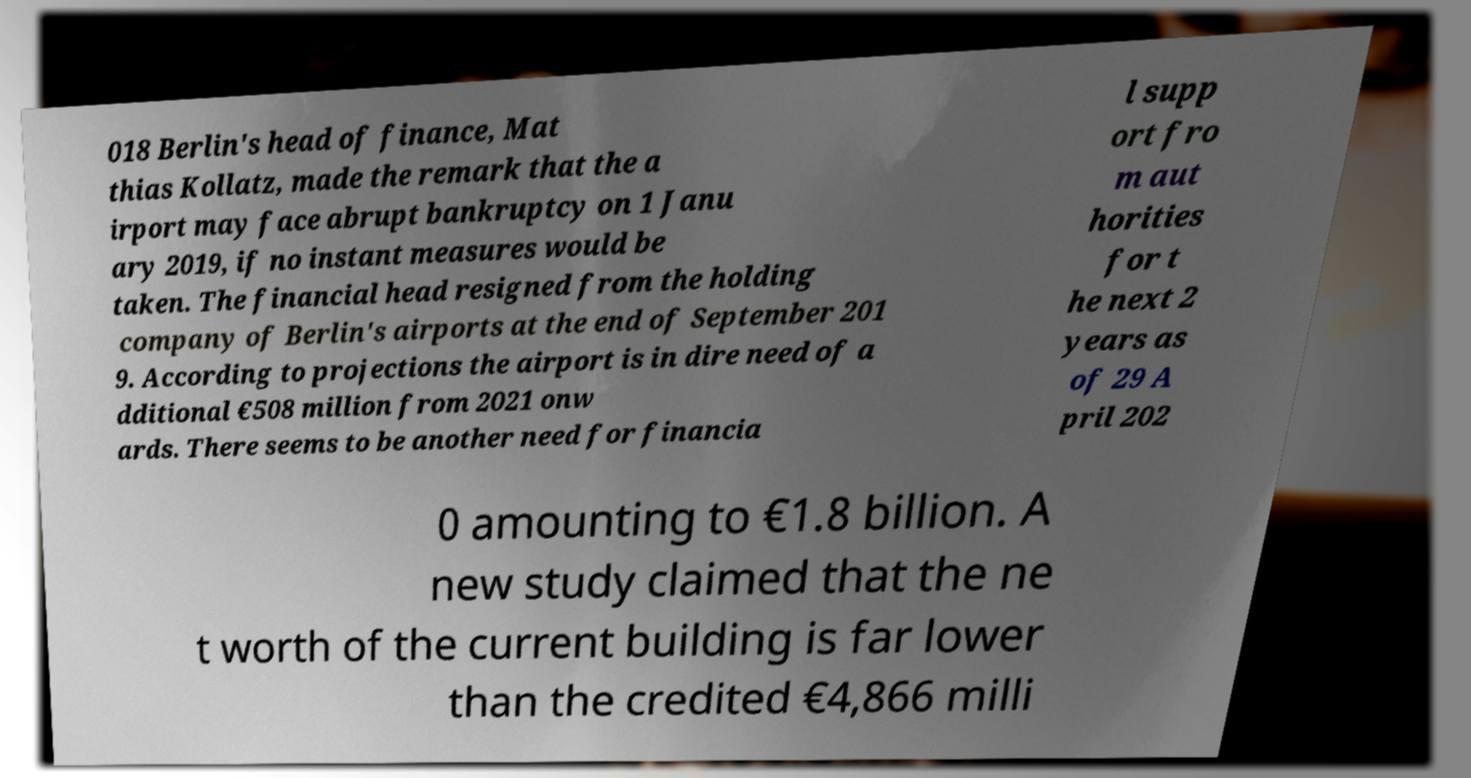Please identify and transcribe the text found in this image. 018 Berlin's head of finance, Mat thias Kollatz, made the remark that the a irport may face abrupt bankruptcy on 1 Janu ary 2019, if no instant measures would be taken. The financial head resigned from the holding company of Berlin's airports at the end of September 201 9. According to projections the airport is in dire need of a dditional €508 million from 2021 onw ards. There seems to be another need for financia l supp ort fro m aut horities for t he next 2 years as of 29 A pril 202 0 amounting to €1.8 billion. A new study claimed that the ne t worth of the current building is far lower than the credited €4,866 milli 